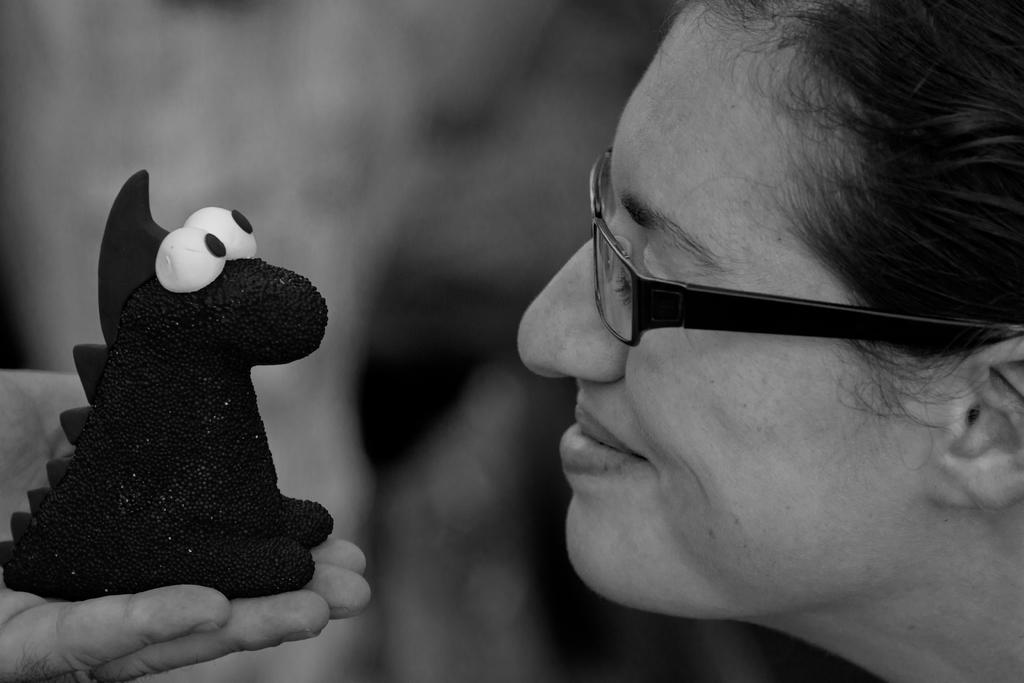What is the color scheme of the image? The image is black and white. Who is present in the image? There is a lady in the image. What can be seen in the bottom left of the image? There is a hand in the bottom left of the image. What is the hand holding? The hand is holding a toy. How would you describe the background of the image? The background of the image is blurred. What type of lettuce is being used as a reward in the image? There is no lettuce or reward present in the image. How much tax is being paid for the toy in the image? There is no mention of tax or payment in the image. 